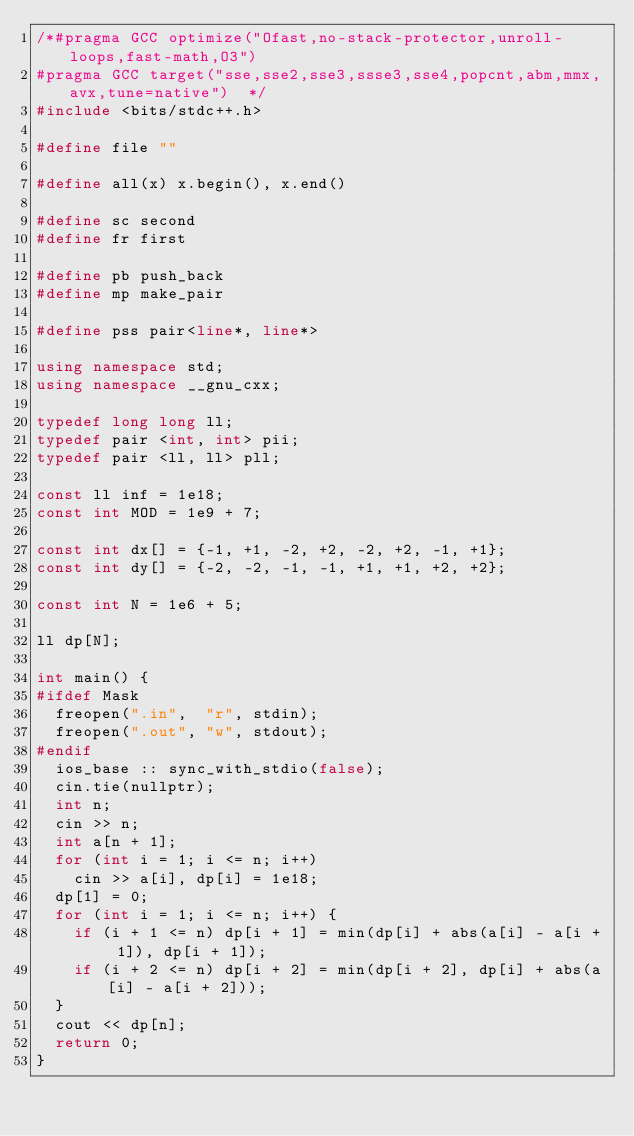<code> <loc_0><loc_0><loc_500><loc_500><_C++_>/*#pragma GCC optimize("Ofast,no-stack-protector,unroll-loops,fast-math,O3")
#pragma GCC target("sse,sse2,sse3,ssse3,sse4,popcnt,abm,mmx,avx,tune=native")  */
#include <bits/stdc++.h>
 
#define file ""
 
#define all(x) x.begin(), x.end()
 
#define sc second
#define fr first
 
#define pb push_back
#define mp make_pair

#define pss pair<line*, line*>
 
using namespace std;
using namespace __gnu_cxx;
 
typedef long long ll;
typedef pair <int, int> pii;
typedef pair <ll, ll> pll;
                                 
const ll inf = 1e18;
const int MOD = 1e9 + 7;

const int dx[] = {-1, +1, -2, +2, -2, +2, -1, +1};
const int dy[] = {-2, -2, -1, -1, +1, +1, +2, +2};

const int N = 1e6 + 5;
           
ll dp[N];

int main() {                
#ifdef Mask                                                         
  freopen(".in", 	"r", stdin);
  freopen(".out", "w", stdout);  
#endif
	ios_base :: sync_with_stdio(false);               
  cin.tie(nullptr); 	
  int n;
  cin >> n;
  int a[n + 1];
  for (int i = 1; i <= n; i++)
  	cin >> a[i], dp[i] = 1e18;
  dp[1] = 0;
  for (int i = 1; i <= n; i++) {
   	if (i + 1 <= n) dp[i + 1] = min(dp[i] + abs(a[i] - a[i + 1]), dp[i + 1]);
   	if (i + 2 <= n) dp[i + 2] = min(dp[i + 2], dp[i] + abs(a[i] - a[i + 2]));
  }
  cout << dp[n];
	return 0;   
}

</code> 